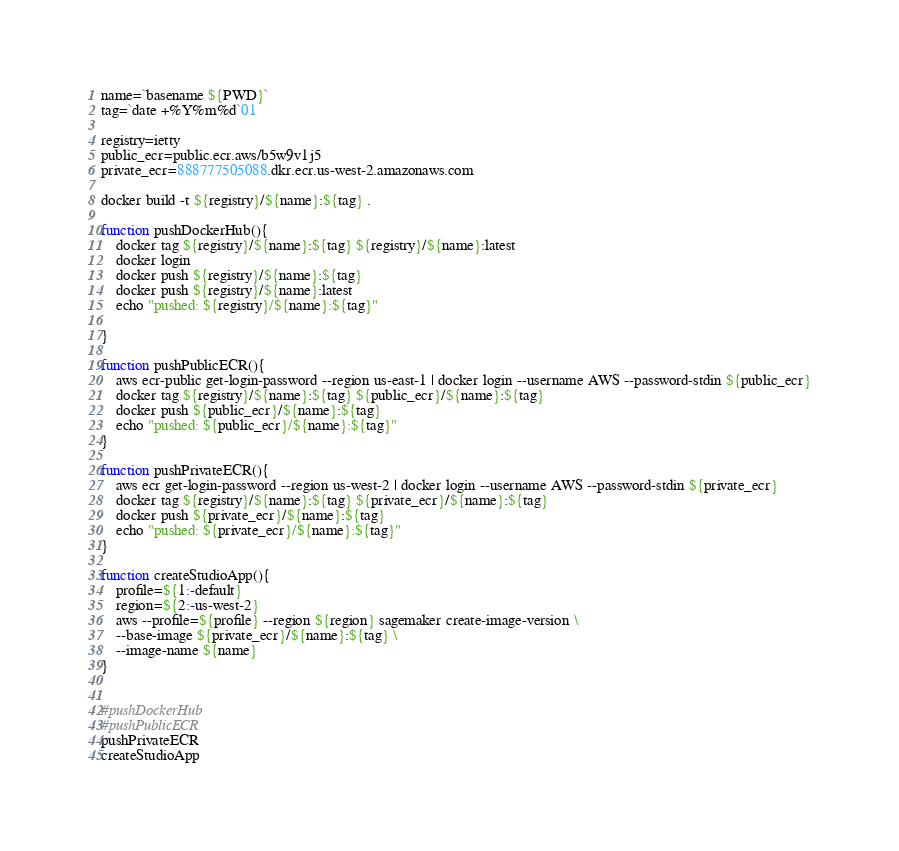Convert code to text. <code><loc_0><loc_0><loc_500><loc_500><_Bash_>name=`basename ${PWD}`
tag=`date +%Y%m%d`01

registry=ietty
public_ecr=public.ecr.aws/b5w9v1j5
private_ecr=888777505088.dkr.ecr.us-west-2.amazonaws.com

docker build -t ${registry}/${name}:${tag} .

function pushDockerHub(){
    docker tag ${registry}/${name}:${tag} ${registry}/${name}:latest
    docker login
    docker push ${registry}/${name}:${tag}
    docker push ${registry}/${name}:latest
    echo "pushed: ${registry}/${name}:${tag}"

}

function pushPublicECR(){
    aws ecr-public get-login-password --region us-east-1 | docker login --username AWS --password-stdin ${public_ecr}
    docker tag ${registry}/${name}:${tag} ${public_ecr}/${name}:${tag}
    docker push ${public_ecr}/${name}:${tag}
    echo "pushed: ${public_ecr}/${name}:${tag}"
}

function pushPrivateECR(){
    aws ecr get-login-password --region us-west-2 | docker login --username AWS --password-stdin ${private_ecr}
    docker tag ${registry}/${name}:${tag} ${private_ecr}/${name}:${tag}
    docker push ${private_ecr}/${name}:${tag}
    echo "pushed: ${private_ecr}/${name}:${tag}"
}

function createStudioApp(){
    profile=${1:-default}
    region=${2:-us-west-2}
    aws --profile=${profile} --region ${region} sagemaker create-image-version \
    --base-image ${private_ecr}/${name}:${tag} \
    --image-name ${name}
}


#pushDockerHub
#pushPublicECR
pushPrivateECR
createStudioApp
</code> 